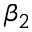Convert formula to latex. <formula><loc_0><loc_0><loc_500><loc_500>\beta _ { 2 }</formula> 